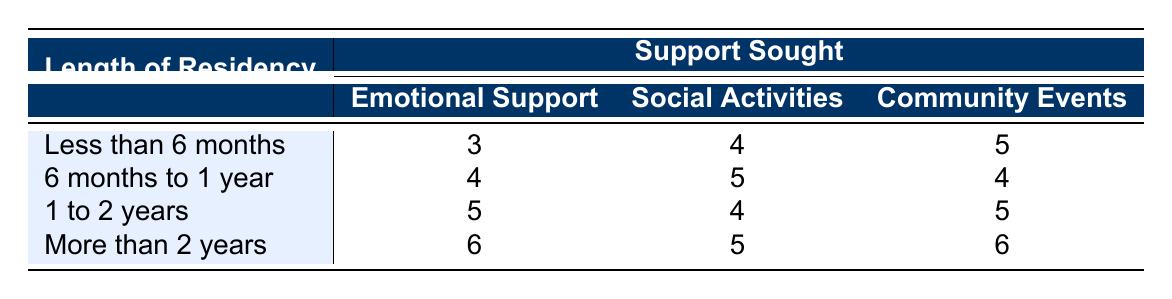What is the satisfaction level for Emotional Support among residents who've lived here for less than 6 months? The table shows the satisfaction level for Emotional Support under the "Less than 6 months" category, which is 3.
Answer: 3 What is the highest satisfaction level for Community Events? By checking the values under Community Events, the highest value is in the "More than 2 years" category, which is 6.
Answer: 6 Do residents who have lived here for 1 to 2 years find Emotional Support more satisfying than those who have been here for less than 6 months? The satisfaction level for Emotional Support for 1 to 2 years is 5, while for less than 6 months it is 3. Therefore, residents living for 1 to 2 years find it more satisfying.
Answer: Yes What is the average satisfaction level for Social Activities across all lengths of residency? The satisfaction levels for Social Activities are 4, 5, 4, and 5, for the respective lengths of residency. To find the average: (4 + 5 + 4 + 5) = 18, and then divide by the number of categories, which is 4. 18/4 = 4.5.
Answer: 4.5 Is the satisfaction level for Community Events consistent across all lengths of residency? Looking at Community Events, the satisfaction levels are 5, 4, 5, and 6 for the respective categories. Since these numbers differ, the levels are not consistent.
Answer: No What is the difference in satisfaction level for Emotional Support between residents with less than 6 months and those with more than 2 years? The satisfaction level for Emotional Support for less than 6 months is 3, while for more than 2 years it is 6. The difference is 6 - 3 = 3.
Answer: 3 Which support type has the highest average satisfaction level across all lengths of residency? To find the average satisfaction levels, we calculate: Emotional Support: (3 + 4 + 5 + 6)/4 = 4.5, Social Activities: (4 + 5 + 4 + 5)/4 = 4.5, Community Events: (5 + 4 + 5 + 6)/4 = 5. The highest average satisfaction level is for Community Events at 5.
Answer: Community Events What is the satisfaction level difference for Community Events between residents who have lived here for 6 months to 1 year and those who have lived here for 1 to 2 years? The satisfaction level for Community Events is 4 for 6 months to 1 year and 5 for 1 to 2 years. The difference is 5 - 4 = 1.
Answer: 1 